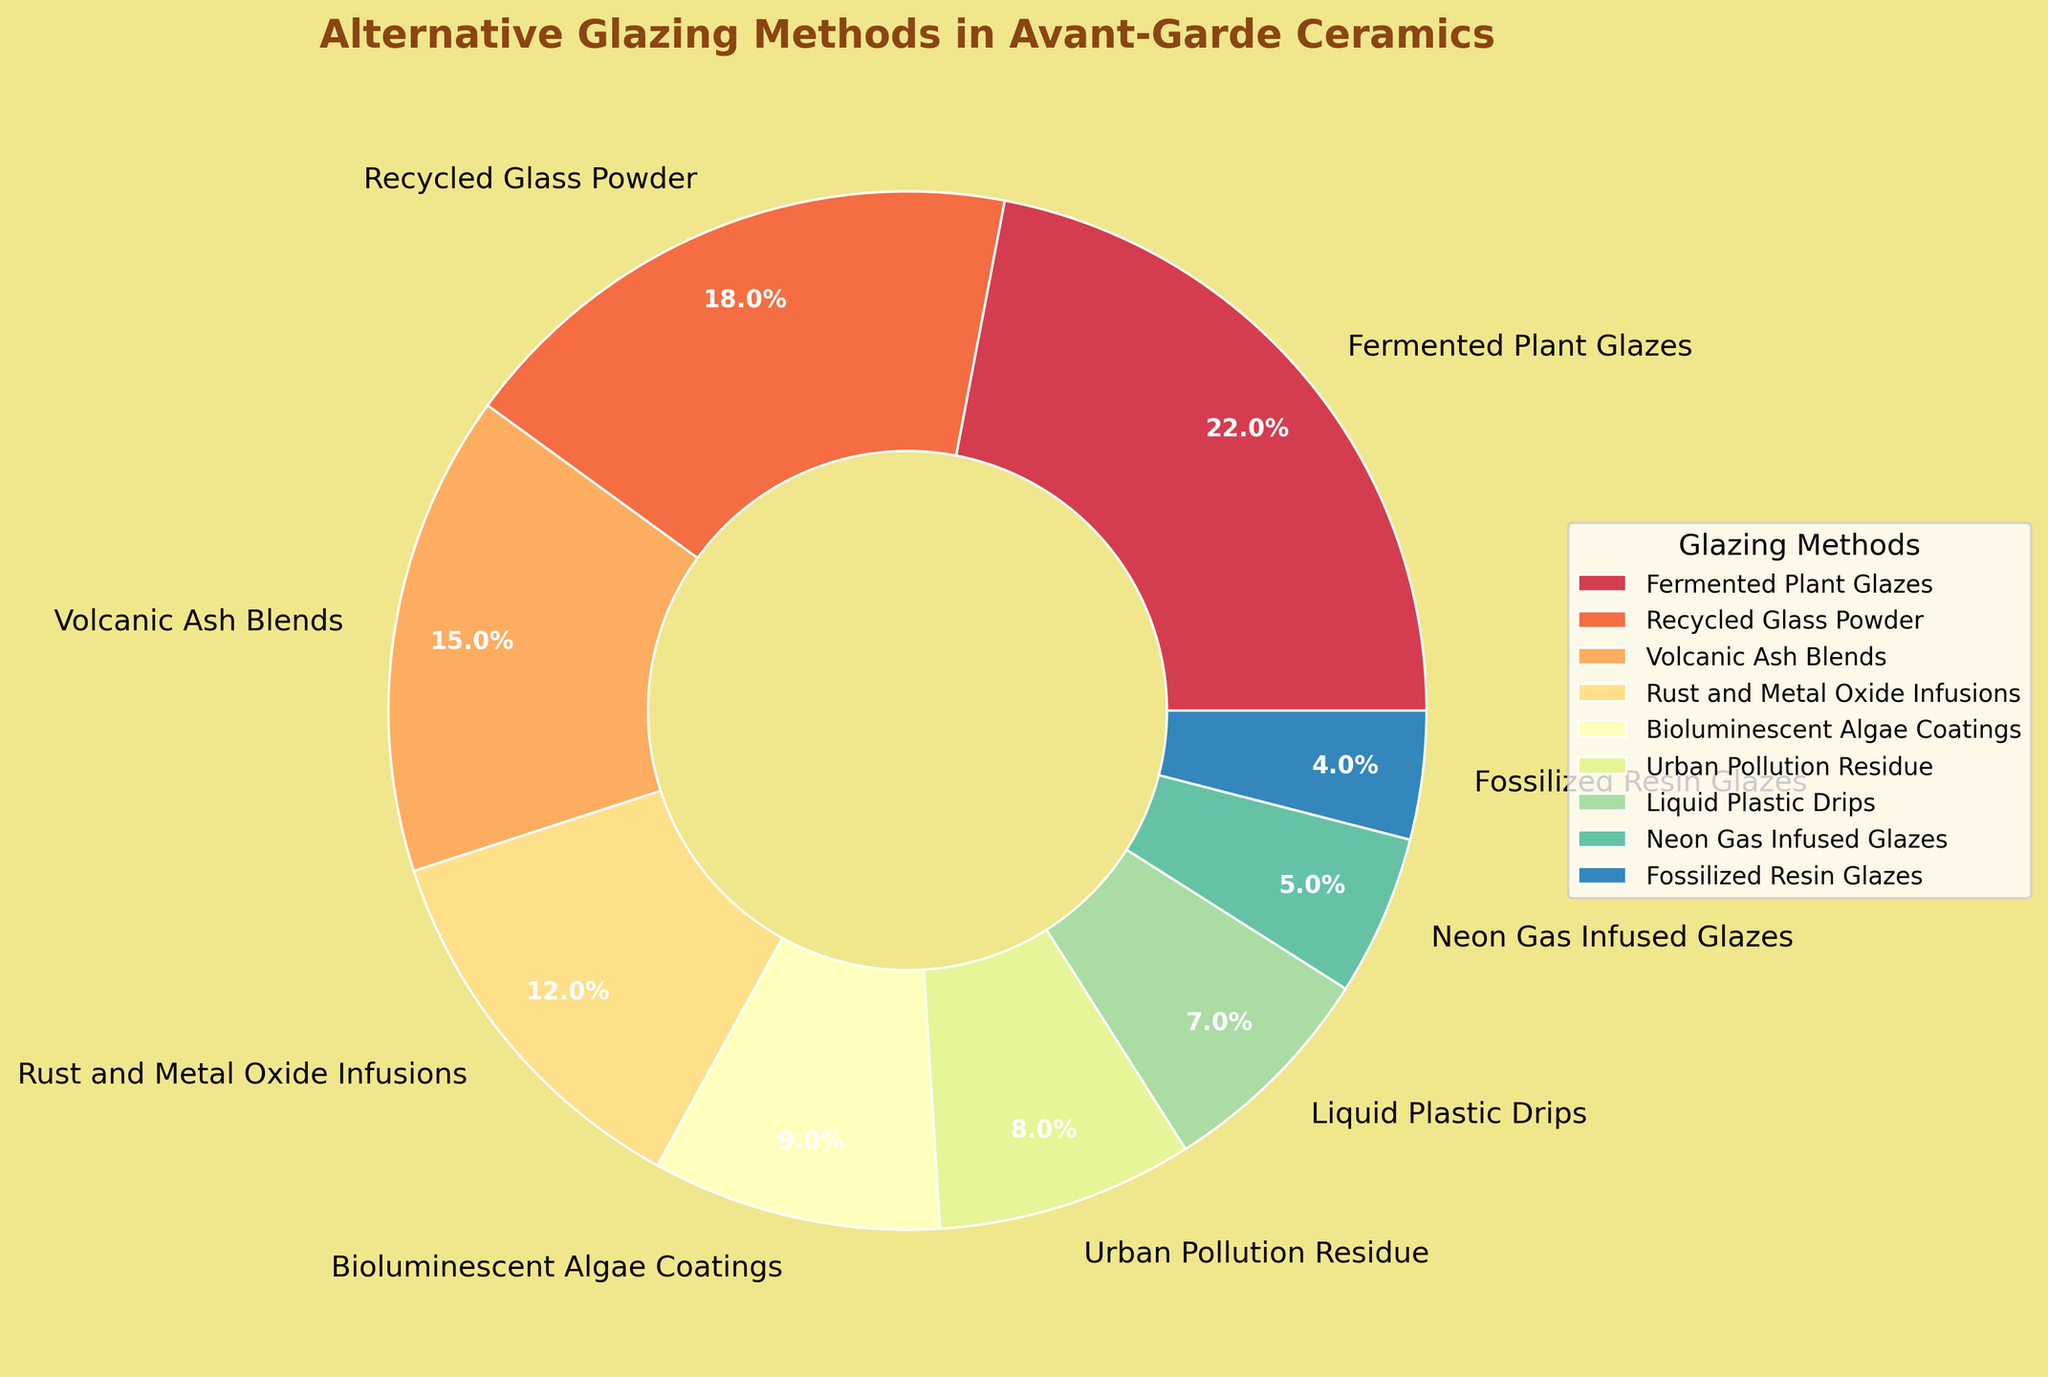what's the combined percentage of Rust and Metal Oxide Infusions and Urban Pollution Residue? To find the combined percentage, add the percentage values of Rust and Metal Oxide Infusions (12%) and Urban Pollution Residue (8%): 12 + 8 = 20
Answer: 20 which glazing method occupies the smallest percentage of the chart? Identify the smallest percentage among the given data, which is Fossilized Resin Glazes with 4%
Answer: Fossilized Resin Glazes how much greater is the percentage of Fermented Plant Glazes compared to Neon Gas Infused Glazes? Subtract the percentage of Neon Gas Infused Glazes (5%) from Fermented Plant Glazes (22%): 22 - 5 = 17
Answer: 17 what is the percentage difference between Bioluminescent Algae Coatings and Liquid Plastic Drips? Subtract the percentage of Liquid Plastic Drips (7%) from Bioluminescent Algae Coatings (9%): 9 - 7 = 2
Answer: 2 which two methods together contribute to 30% of the glazing methods? Add percentages of different combinations to find a pair that sums to 30%. The combination of Recycled Glass Powder (18%) and Volcanic Ash Blends (15%) sums to 33%. Try Recycled Glass Powder (18%) and Rust and Metal Oxide Infusions (12%), which sums to 30%: 18 + 12 = 30
Answer: Recycled Glass Powder and Rust and Metal Oxide Infusions how does the proportion of Bioluminescent Algae Coatings compare to the proportion of Urban Pollution Residue? Compare the percentages directly: Bioluminescent Algae Coatings (9%) is greater than Urban Pollution Residue (8%) by 1%
Answer: Bioluminescent Algae Coatings is 1% greater what is the median value of the listed glazing methods? Arrange the percentages in ascending order: [4, 5, 7, 8, 9, 12, 15, 18, 22]. The median value is the middle number (9% for Bioluminescent Algae Coatings) as there are 9 values
Answer: 9 which three methods have the highest combined percentage? Identify the three highest percentages: Fermented Plant Glazes (22%), Recycled Glass Powder (18%), and Volcanic Ash Blends (15%). Add them: 22 + 18 + 15 = 55
Answer: Fermented Plant Glazes, Recycled Glass Powder, and Volcanic Ash Blends which glazing method has a percentage that is one-third of Fermented Plant Glazes? Calculate one third of Fermented Plant Glazes' percentage (22%): 22 / 3 ≈ 7.33. Liquid Plastic Drips has a percentage close to this value (7%)
Answer: Liquid Plastic Drips 